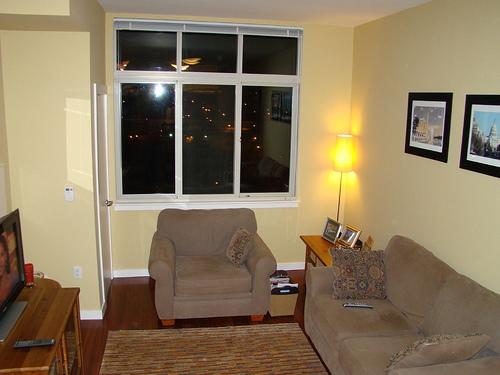Which pane shows the flash?
Short answer required. Left. Are the blinds raised?
Answer briefly. Yes. Is electricity being wasted in this room?
Quick response, please. Yes. 